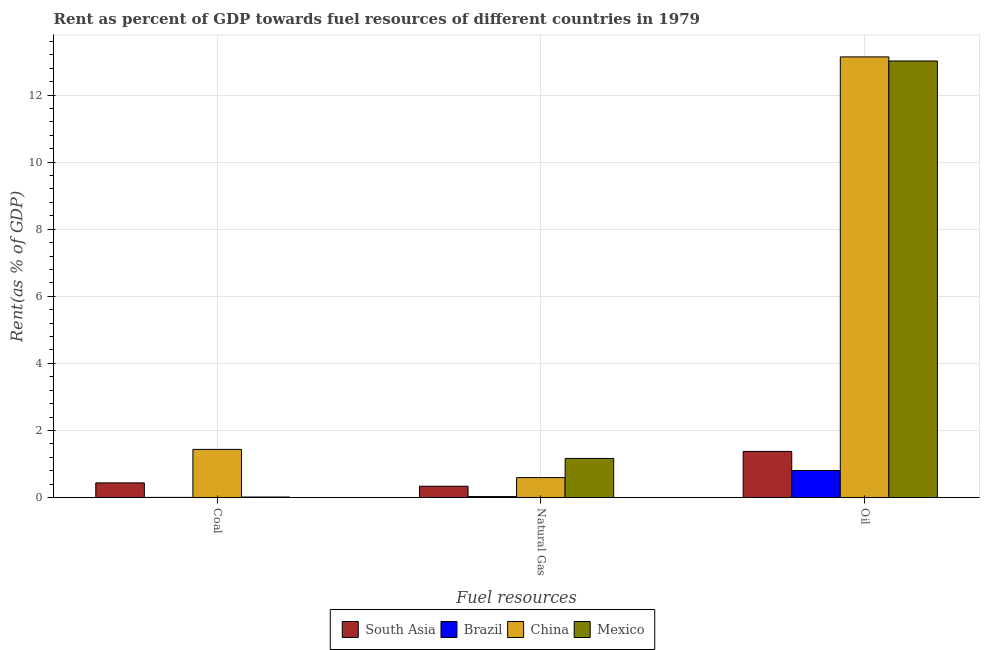How many different coloured bars are there?
Your answer should be very brief. 4. How many groups of bars are there?
Offer a very short reply. 3. Are the number of bars per tick equal to the number of legend labels?
Provide a succinct answer. Yes. What is the label of the 2nd group of bars from the left?
Provide a succinct answer. Natural Gas. What is the rent towards natural gas in Mexico?
Provide a succinct answer. 1.16. Across all countries, what is the maximum rent towards coal?
Offer a terse response. 1.43. Across all countries, what is the minimum rent towards coal?
Give a very brief answer. 0. In which country was the rent towards oil minimum?
Offer a very short reply. Brazil. What is the total rent towards coal in the graph?
Make the answer very short. 1.89. What is the difference between the rent towards natural gas in Brazil and that in Mexico?
Your answer should be compact. -1.14. What is the difference between the rent towards oil in China and the rent towards natural gas in South Asia?
Your response must be concise. 12.8. What is the average rent towards natural gas per country?
Make the answer very short. 0.53. What is the difference between the rent towards oil and rent towards natural gas in Brazil?
Offer a very short reply. 0.78. In how many countries, is the rent towards natural gas greater than 8.8 %?
Keep it short and to the point. 0. What is the ratio of the rent towards natural gas in South Asia to that in Mexico?
Give a very brief answer. 0.29. What is the difference between the highest and the second highest rent towards oil?
Provide a succinct answer. 0.12. What is the difference between the highest and the lowest rent towards natural gas?
Keep it short and to the point. 1.14. In how many countries, is the rent towards natural gas greater than the average rent towards natural gas taken over all countries?
Your answer should be compact. 2. Is the sum of the rent towards coal in China and Mexico greater than the maximum rent towards oil across all countries?
Ensure brevity in your answer.  No. What does the 3rd bar from the left in Natural Gas represents?
Offer a terse response. China. What is the difference between two consecutive major ticks on the Y-axis?
Offer a terse response. 2. Where does the legend appear in the graph?
Provide a short and direct response. Bottom center. How many legend labels are there?
Your response must be concise. 4. What is the title of the graph?
Provide a short and direct response. Rent as percent of GDP towards fuel resources of different countries in 1979. What is the label or title of the X-axis?
Make the answer very short. Fuel resources. What is the label or title of the Y-axis?
Your answer should be compact. Rent(as % of GDP). What is the Rent(as % of GDP) of South Asia in Coal?
Provide a succinct answer. 0.44. What is the Rent(as % of GDP) in Brazil in Coal?
Your answer should be compact. 0. What is the Rent(as % of GDP) in China in Coal?
Your response must be concise. 1.43. What is the Rent(as % of GDP) of Mexico in Coal?
Give a very brief answer. 0.01. What is the Rent(as % of GDP) of South Asia in Natural Gas?
Ensure brevity in your answer.  0.34. What is the Rent(as % of GDP) in Brazil in Natural Gas?
Your response must be concise. 0.03. What is the Rent(as % of GDP) in China in Natural Gas?
Offer a very short reply. 0.59. What is the Rent(as % of GDP) of Mexico in Natural Gas?
Your answer should be very brief. 1.16. What is the Rent(as % of GDP) of South Asia in Oil?
Make the answer very short. 1.37. What is the Rent(as % of GDP) in Brazil in Oil?
Give a very brief answer. 0.81. What is the Rent(as % of GDP) in China in Oil?
Provide a succinct answer. 13.14. What is the Rent(as % of GDP) in Mexico in Oil?
Make the answer very short. 13.02. Across all Fuel resources, what is the maximum Rent(as % of GDP) of South Asia?
Keep it short and to the point. 1.37. Across all Fuel resources, what is the maximum Rent(as % of GDP) in Brazil?
Provide a succinct answer. 0.81. Across all Fuel resources, what is the maximum Rent(as % of GDP) in China?
Your response must be concise. 13.14. Across all Fuel resources, what is the maximum Rent(as % of GDP) of Mexico?
Your response must be concise. 13.02. Across all Fuel resources, what is the minimum Rent(as % of GDP) of South Asia?
Your answer should be very brief. 0.34. Across all Fuel resources, what is the minimum Rent(as % of GDP) in Brazil?
Keep it short and to the point. 0. Across all Fuel resources, what is the minimum Rent(as % of GDP) of China?
Provide a short and direct response. 0.59. Across all Fuel resources, what is the minimum Rent(as % of GDP) in Mexico?
Your response must be concise. 0.01. What is the total Rent(as % of GDP) in South Asia in the graph?
Keep it short and to the point. 2.15. What is the total Rent(as % of GDP) of Brazil in the graph?
Your answer should be very brief. 0.83. What is the total Rent(as % of GDP) in China in the graph?
Your response must be concise. 15.17. What is the total Rent(as % of GDP) in Mexico in the graph?
Your answer should be very brief. 14.2. What is the difference between the Rent(as % of GDP) in South Asia in Coal and that in Natural Gas?
Offer a terse response. 0.1. What is the difference between the Rent(as % of GDP) in Brazil in Coal and that in Natural Gas?
Your answer should be compact. -0.03. What is the difference between the Rent(as % of GDP) in China in Coal and that in Natural Gas?
Provide a short and direct response. 0.84. What is the difference between the Rent(as % of GDP) of Mexico in Coal and that in Natural Gas?
Give a very brief answer. -1.15. What is the difference between the Rent(as % of GDP) in South Asia in Coal and that in Oil?
Your answer should be compact. -0.94. What is the difference between the Rent(as % of GDP) in Brazil in Coal and that in Oil?
Your answer should be very brief. -0.8. What is the difference between the Rent(as % of GDP) in China in Coal and that in Oil?
Your answer should be compact. -11.7. What is the difference between the Rent(as % of GDP) of Mexico in Coal and that in Oil?
Provide a succinct answer. -13. What is the difference between the Rent(as % of GDP) in South Asia in Natural Gas and that in Oil?
Provide a short and direct response. -1.04. What is the difference between the Rent(as % of GDP) of Brazil in Natural Gas and that in Oil?
Offer a very short reply. -0.78. What is the difference between the Rent(as % of GDP) of China in Natural Gas and that in Oil?
Provide a short and direct response. -12.55. What is the difference between the Rent(as % of GDP) in Mexico in Natural Gas and that in Oil?
Offer a terse response. -11.85. What is the difference between the Rent(as % of GDP) in South Asia in Coal and the Rent(as % of GDP) in Brazil in Natural Gas?
Give a very brief answer. 0.41. What is the difference between the Rent(as % of GDP) of South Asia in Coal and the Rent(as % of GDP) of China in Natural Gas?
Your answer should be very brief. -0.16. What is the difference between the Rent(as % of GDP) of South Asia in Coal and the Rent(as % of GDP) of Mexico in Natural Gas?
Ensure brevity in your answer.  -0.73. What is the difference between the Rent(as % of GDP) of Brazil in Coal and the Rent(as % of GDP) of China in Natural Gas?
Make the answer very short. -0.59. What is the difference between the Rent(as % of GDP) of Brazil in Coal and the Rent(as % of GDP) of Mexico in Natural Gas?
Your answer should be very brief. -1.16. What is the difference between the Rent(as % of GDP) of China in Coal and the Rent(as % of GDP) of Mexico in Natural Gas?
Ensure brevity in your answer.  0.27. What is the difference between the Rent(as % of GDP) of South Asia in Coal and the Rent(as % of GDP) of Brazil in Oil?
Offer a terse response. -0.37. What is the difference between the Rent(as % of GDP) of South Asia in Coal and the Rent(as % of GDP) of China in Oil?
Your answer should be very brief. -12.7. What is the difference between the Rent(as % of GDP) of South Asia in Coal and the Rent(as % of GDP) of Mexico in Oil?
Make the answer very short. -12.58. What is the difference between the Rent(as % of GDP) in Brazil in Coal and the Rent(as % of GDP) in China in Oil?
Ensure brevity in your answer.  -13.14. What is the difference between the Rent(as % of GDP) of Brazil in Coal and the Rent(as % of GDP) of Mexico in Oil?
Your response must be concise. -13.02. What is the difference between the Rent(as % of GDP) in China in Coal and the Rent(as % of GDP) in Mexico in Oil?
Make the answer very short. -11.58. What is the difference between the Rent(as % of GDP) of South Asia in Natural Gas and the Rent(as % of GDP) of Brazil in Oil?
Make the answer very short. -0.47. What is the difference between the Rent(as % of GDP) in South Asia in Natural Gas and the Rent(as % of GDP) in China in Oil?
Offer a terse response. -12.8. What is the difference between the Rent(as % of GDP) in South Asia in Natural Gas and the Rent(as % of GDP) in Mexico in Oil?
Provide a succinct answer. -12.68. What is the difference between the Rent(as % of GDP) of Brazil in Natural Gas and the Rent(as % of GDP) of China in Oil?
Ensure brevity in your answer.  -13.11. What is the difference between the Rent(as % of GDP) in Brazil in Natural Gas and the Rent(as % of GDP) in Mexico in Oil?
Keep it short and to the point. -12.99. What is the difference between the Rent(as % of GDP) in China in Natural Gas and the Rent(as % of GDP) in Mexico in Oil?
Provide a short and direct response. -12.42. What is the average Rent(as % of GDP) of South Asia per Fuel resources?
Your answer should be very brief. 0.72. What is the average Rent(as % of GDP) in Brazil per Fuel resources?
Offer a terse response. 0.28. What is the average Rent(as % of GDP) of China per Fuel resources?
Offer a very short reply. 5.06. What is the average Rent(as % of GDP) in Mexico per Fuel resources?
Your answer should be very brief. 4.73. What is the difference between the Rent(as % of GDP) of South Asia and Rent(as % of GDP) of Brazil in Coal?
Ensure brevity in your answer.  0.43. What is the difference between the Rent(as % of GDP) in South Asia and Rent(as % of GDP) in China in Coal?
Your answer should be very brief. -1. What is the difference between the Rent(as % of GDP) in South Asia and Rent(as % of GDP) in Mexico in Coal?
Make the answer very short. 0.42. What is the difference between the Rent(as % of GDP) in Brazil and Rent(as % of GDP) in China in Coal?
Your answer should be very brief. -1.43. What is the difference between the Rent(as % of GDP) of Brazil and Rent(as % of GDP) of Mexico in Coal?
Offer a terse response. -0.01. What is the difference between the Rent(as % of GDP) in China and Rent(as % of GDP) in Mexico in Coal?
Provide a succinct answer. 1.42. What is the difference between the Rent(as % of GDP) of South Asia and Rent(as % of GDP) of Brazil in Natural Gas?
Ensure brevity in your answer.  0.31. What is the difference between the Rent(as % of GDP) of South Asia and Rent(as % of GDP) of China in Natural Gas?
Give a very brief answer. -0.26. What is the difference between the Rent(as % of GDP) in South Asia and Rent(as % of GDP) in Mexico in Natural Gas?
Your answer should be very brief. -0.83. What is the difference between the Rent(as % of GDP) of Brazil and Rent(as % of GDP) of China in Natural Gas?
Ensure brevity in your answer.  -0.57. What is the difference between the Rent(as % of GDP) in Brazil and Rent(as % of GDP) in Mexico in Natural Gas?
Give a very brief answer. -1.14. What is the difference between the Rent(as % of GDP) in China and Rent(as % of GDP) in Mexico in Natural Gas?
Your answer should be compact. -0.57. What is the difference between the Rent(as % of GDP) of South Asia and Rent(as % of GDP) of Brazil in Oil?
Give a very brief answer. 0.57. What is the difference between the Rent(as % of GDP) in South Asia and Rent(as % of GDP) in China in Oil?
Give a very brief answer. -11.76. What is the difference between the Rent(as % of GDP) in South Asia and Rent(as % of GDP) in Mexico in Oil?
Offer a terse response. -11.64. What is the difference between the Rent(as % of GDP) of Brazil and Rent(as % of GDP) of China in Oil?
Provide a short and direct response. -12.33. What is the difference between the Rent(as % of GDP) in Brazil and Rent(as % of GDP) in Mexico in Oil?
Make the answer very short. -12.21. What is the difference between the Rent(as % of GDP) of China and Rent(as % of GDP) of Mexico in Oil?
Make the answer very short. 0.12. What is the ratio of the Rent(as % of GDP) in South Asia in Coal to that in Natural Gas?
Your answer should be compact. 1.3. What is the ratio of the Rent(as % of GDP) of Brazil in Coal to that in Natural Gas?
Make the answer very short. 0.07. What is the ratio of the Rent(as % of GDP) of China in Coal to that in Natural Gas?
Your answer should be very brief. 2.42. What is the ratio of the Rent(as % of GDP) of Mexico in Coal to that in Natural Gas?
Offer a terse response. 0.01. What is the ratio of the Rent(as % of GDP) of South Asia in Coal to that in Oil?
Give a very brief answer. 0.32. What is the ratio of the Rent(as % of GDP) of Brazil in Coal to that in Oil?
Offer a very short reply. 0. What is the ratio of the Rent(as % of GDP) of China in Coal to that in Oil?
Your answer should be compact. 0.11. What is the ratio of the Rent(as % of GDP) in Mexico in Coal to that in Oil?
Make the answer very short. 0. What is the ratio of the Rent(as % of GDP) of South Asia in Natural Gas to that in Oil?
Keep it short and to the point. 0.24. What is the ratio of the Rent(as % of GDP) of Brazil in Natural Gas to that in Oil?
Ensure brevity in your answer.  0.03. What is the ratio of the Rent(as % of GDP) in China in Natural Gas to that in Oil?
Your answer should be compact. 0.05. What is the ratio of the Rent(as % of GDP) in Mexico in Natural Gas to that in Oil?
Make the answer very short. 0.09. What is the difference between the highest and the second highest Rent(as % of GDP) of South Asia?
Provide a short and direct response. 0.94. What is the difference between the highest and the second highest Rent(as % of GDP) in Brazil?
Provide a short and direct response. 0.78. What is the difference between the highest and the second highest Rent(as % of GDP) of China?
Make the answer very short. 11.7. What is the difference between the highest and the second highest Rent(as % of GDP) in Mexico?
Make the answer very short. 11.85. What is the difference between the highest and the lowest Rent(as % of GDP) of South Asia?
Offer a terse response. 1.04. What is the difference between the highest and the lowest Rent(as % of GDP) of Brazil?
Give a very brief answer. 0.8. What is the difference between the highest and the lowest Rent(as % of GDP) in China?
Ensure brevity in your answer.  12.55. What is the difference between the highest and the lowest Rent(as % of GDP) in Mexico?
Keep it short and to the point. 13. 